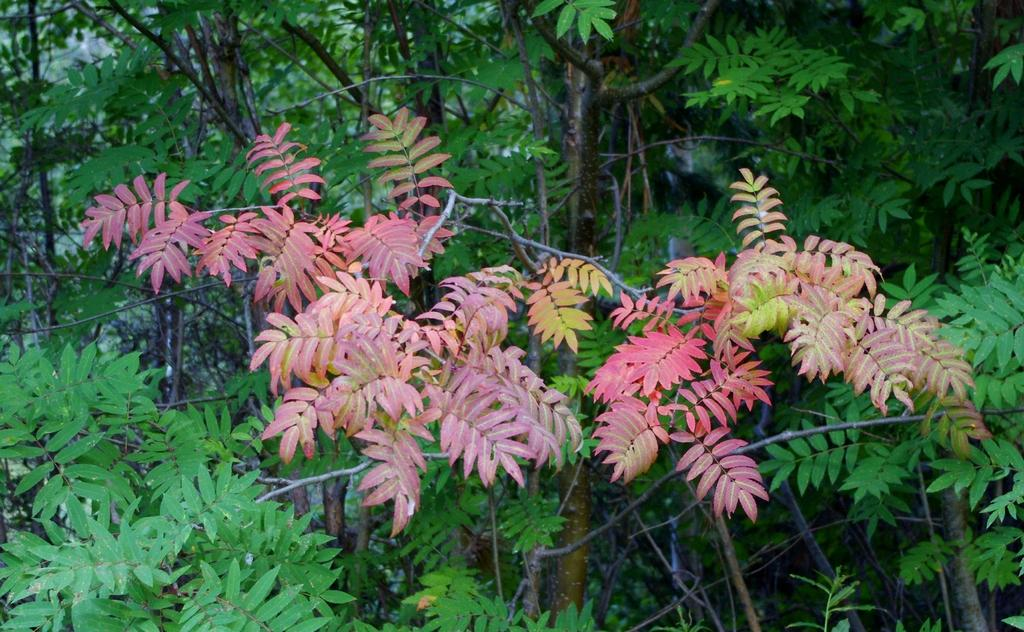What type of vegetation can be seen in the image? There are trees in the image. What type of mint is growing alongside the road in the image? There is no road or mint present in the image; it only features trees. What songs can be heard playing in the background of the image? There is no audio or background music in the image, as it is a still photograph. 